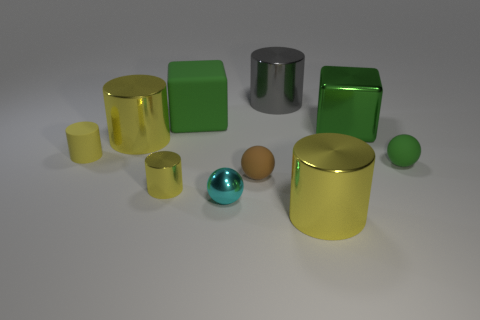There is a tiny object that is the same color as the tiny matte cylinder; what is its material?
Provide a succinct answer. Metal. There is a brown sphere; are there any brown matte balls behind it?
Keep it short and to the point. No. There is a brown object; is it the same size as the cyan object that is left of the green matte ball?
Offer a terse response. Yes. How many other things are there of the same material as the tiny brown object?
Your answer should be compact. 3. What is the shape of the metallic object that is in front of the small green matte ball and on the right side of the cyan ball?
Your answer should be compact. Cylinder. Does the yellow metallic cylinder that is behind the small green sphere have the same size as the green matte thing on the right side of the small cyan shiny thing?
Keep it short and to the point. No. What shape is the large green object that is the same material as the brown thing?
Your answer should be very brief. Cube. Is there anything else that has the same shape as the tiny brown object?
Your answer should be compact. Yes. There is a tiny rubber object that is to the left of the large yellow shiny object to the left of the big green rubber object that is behind the green metallic thing; what color is it?
Give a very brief answer. Yellow. Are there fewer cyan balls behind the yellow rubber object than tiny cylinders on the left side of the cyan metallic object?
Make the answer very short. Yes. 